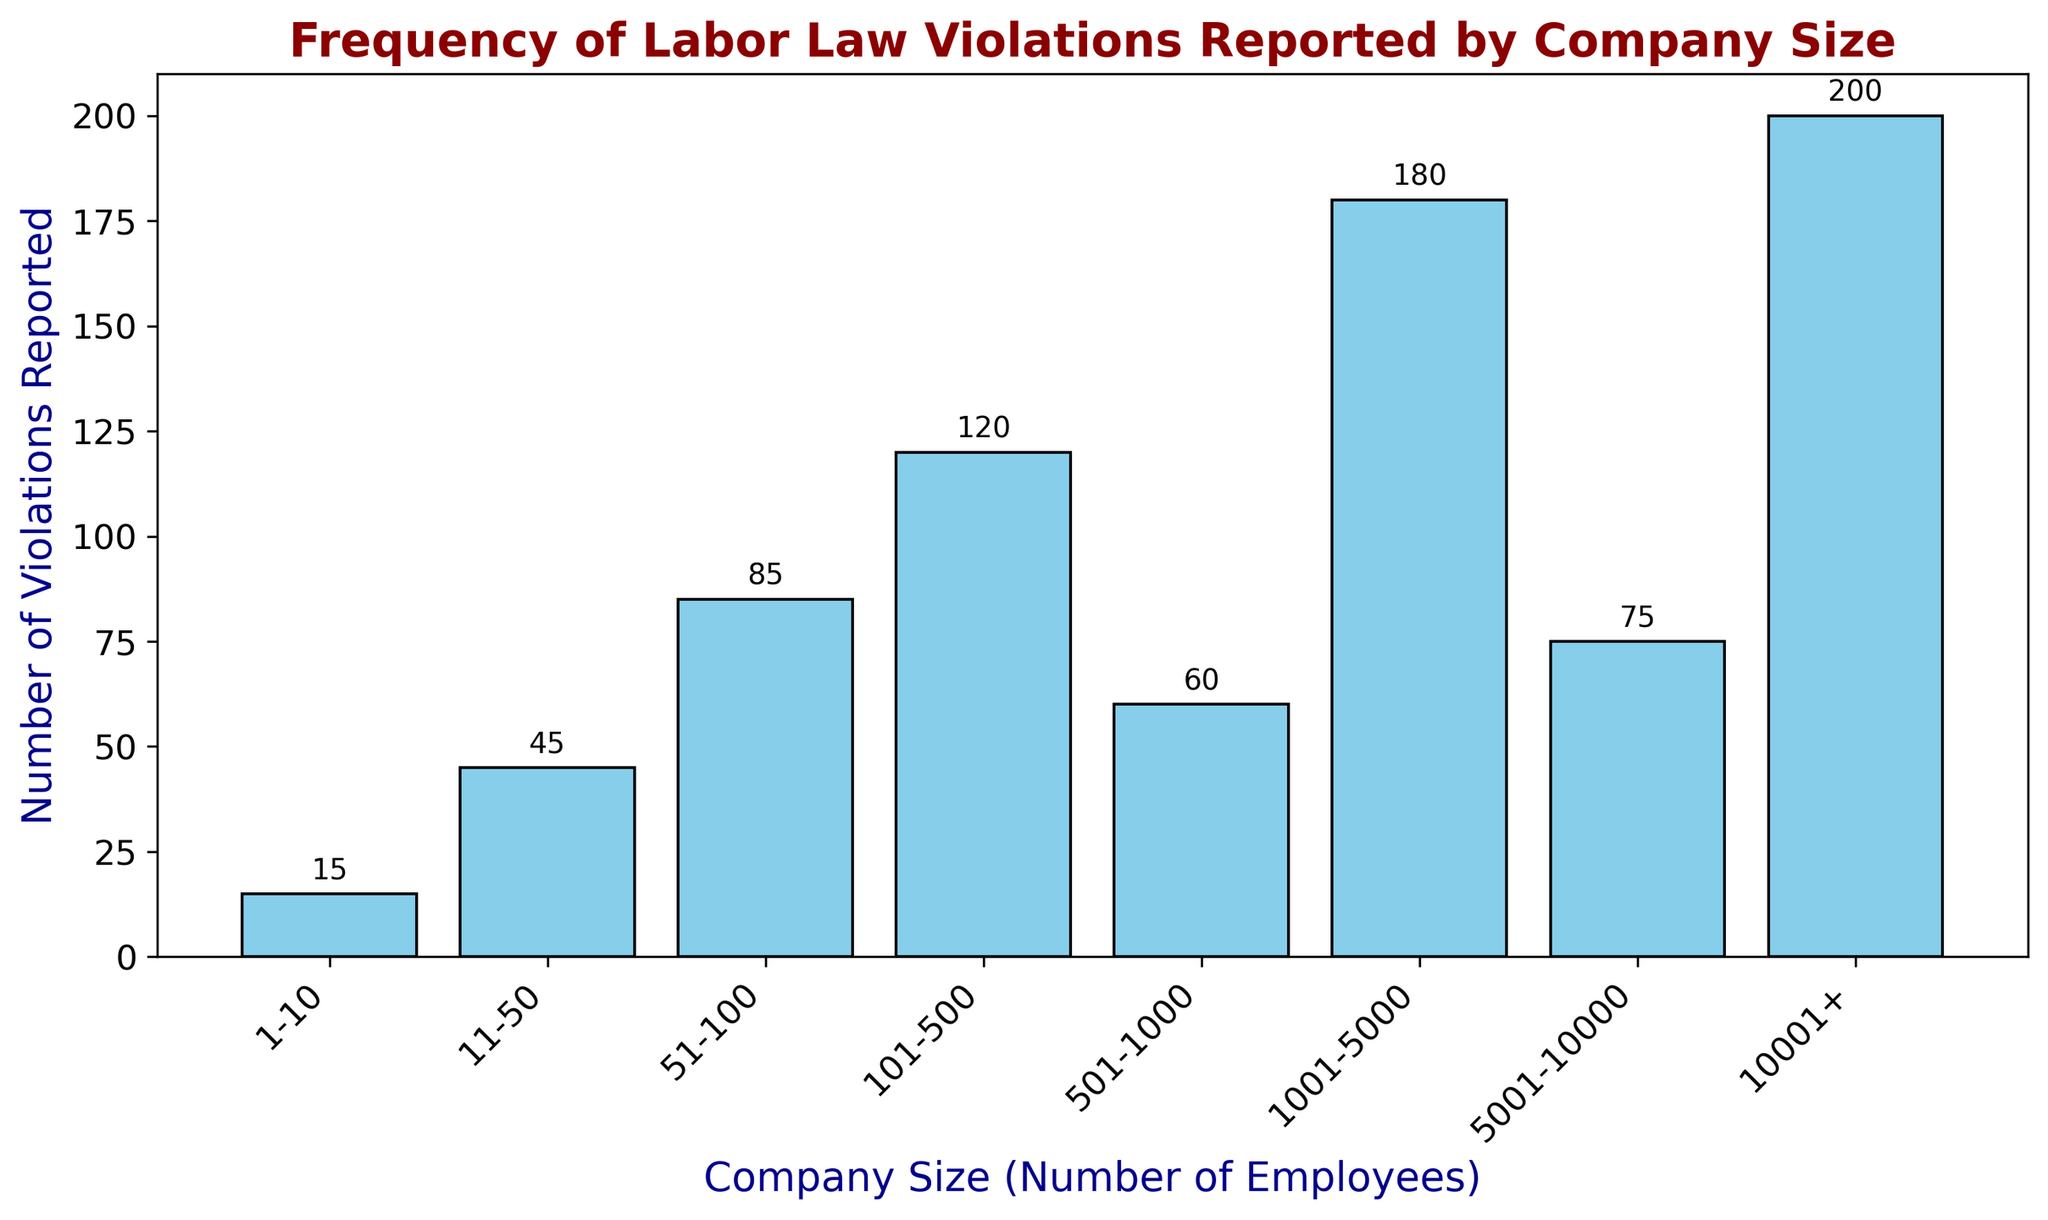What is the range of the number of violations reported across all company sizes? The smallest bar represents 15 violations and the largest bar represents 200 violations. The range is the difference between the maximum and minimum values. Therefore, the range is 200 - 15 = 185.
Answer: 185 Which company size category reported the highest number of violations? The bars represent the number of violations reported for each company size category. The tallest bar, indicating the highest number of violations, corresponds to the "10001+" category with 200 violations.
Answer: 10001+ What is the combined number of violations reported by companies with 1-100 employees? The number of violations reported by companies in the 1-10, 11-50, and 51-100 employee categories are 15, 45, and 85, respectively. Adding these together, 15 + 45 + 85 = 145.
Answer: 145 Which company size category lies between the highest and the lowest in terms of the number of violations reported? The lowest is 1-10 with 15 violations, and the highest is 10001+ with 200 violations. The category that lies approximately in the middle in terms of violations is 101-500 with 120 violations.
Answer: 101-500 How many more violations were reported by companies with 10001+ employees compared to companies with 501-1000 employees? The number of violations reported by 10001+ employees is 200, and the number by 501-1000 employees is 60. The difference is 200 - 60 = 140.
Answer: 140 What is the average number of violations reported by companies with 5001 employees and more? The number of violations reported by 5001-10000 is 75 and by 10001+ is 200. The average is calculated by (75 + 200) / 2 = 137.5.
Answer: 137.5 Which two company size categories have reported the same or nearest number of violations? By examining the bar heights, the two categories with the most similar number of violations are 501-1000 employees (60 violations) and 5001-10000 employees (75 violations).
Answer: 501-1000 and 5001-10000 How do the number of reported violations for companies with 101-500 employees compare to those with 501-1000 employees? The number of violations reported by companies with 101-500 employees is 120, which is twice as much as the 60 violations reported by companies with 501-1000 employees.
Answer: twice as much What percentage of the total reported violations come from companies with 10001+ employees? First, find the total number of violations by summing all values: 15 + 45 + 85 + 120 + 60 + 180 + 75 + 200 = 780. The number of violations from 10001+ employees is 200. The percentage is calculated by (200 / 780) * 100 = ~25.64%.
Answer: ~25.64% What is the total number of reported violations for companies with fewer than 500 employees? Companies with fewer than 500 employees include the following categories: 1-10 (15), 11-50 (45), 51-100 (85), and 101-500 (120). Adding these together, 15 + 45 + 85 + 120 = 265.
Answer: 265 